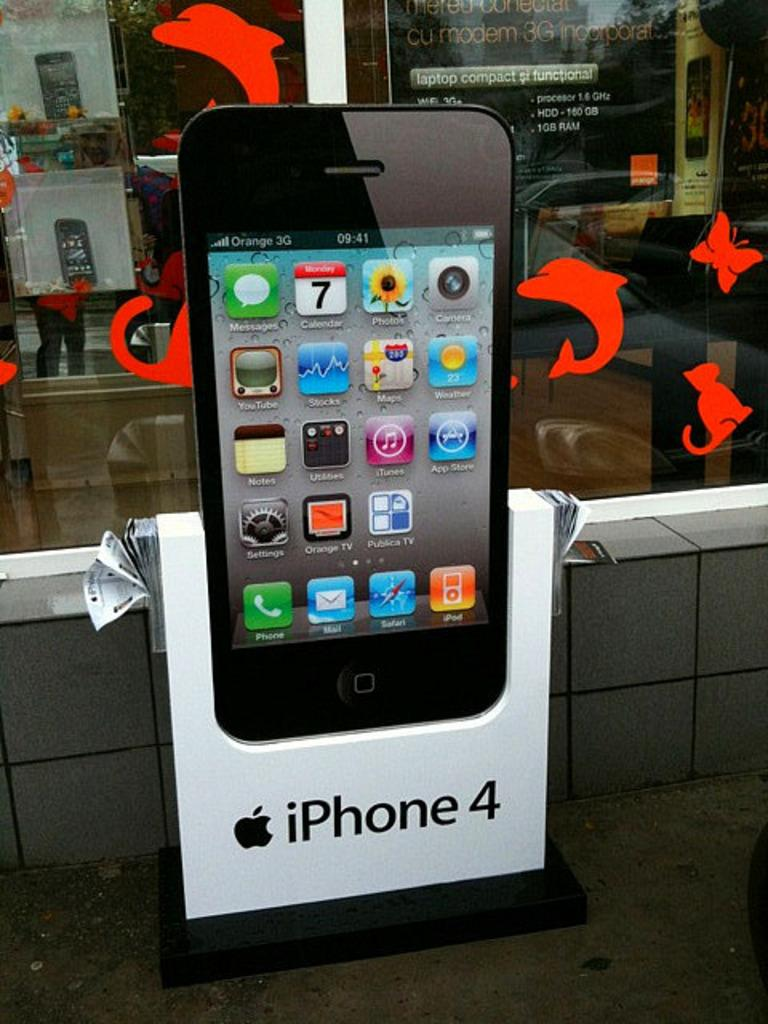<image>
Write a terse but informative summary of the picture. A sign for the iPhone 4 is posted outside a window. 